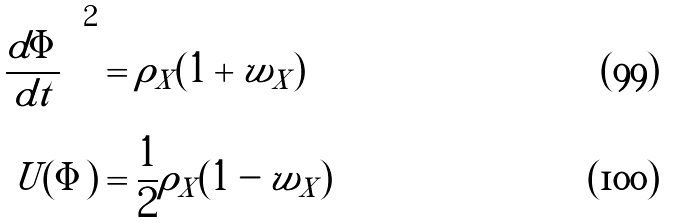<formula> <loc_0><loc_0><loc_500><loc_500>\left ( \frac { d \Phi } { d t } \right ) ^ { 2 } & = \rho _ { X } ( 1 + w _ { X } ) \\ U ( \Phi ) & = \frac { 1 } { 2 } \rho _ { X } ( 1 - w _ { X } )</formula> 